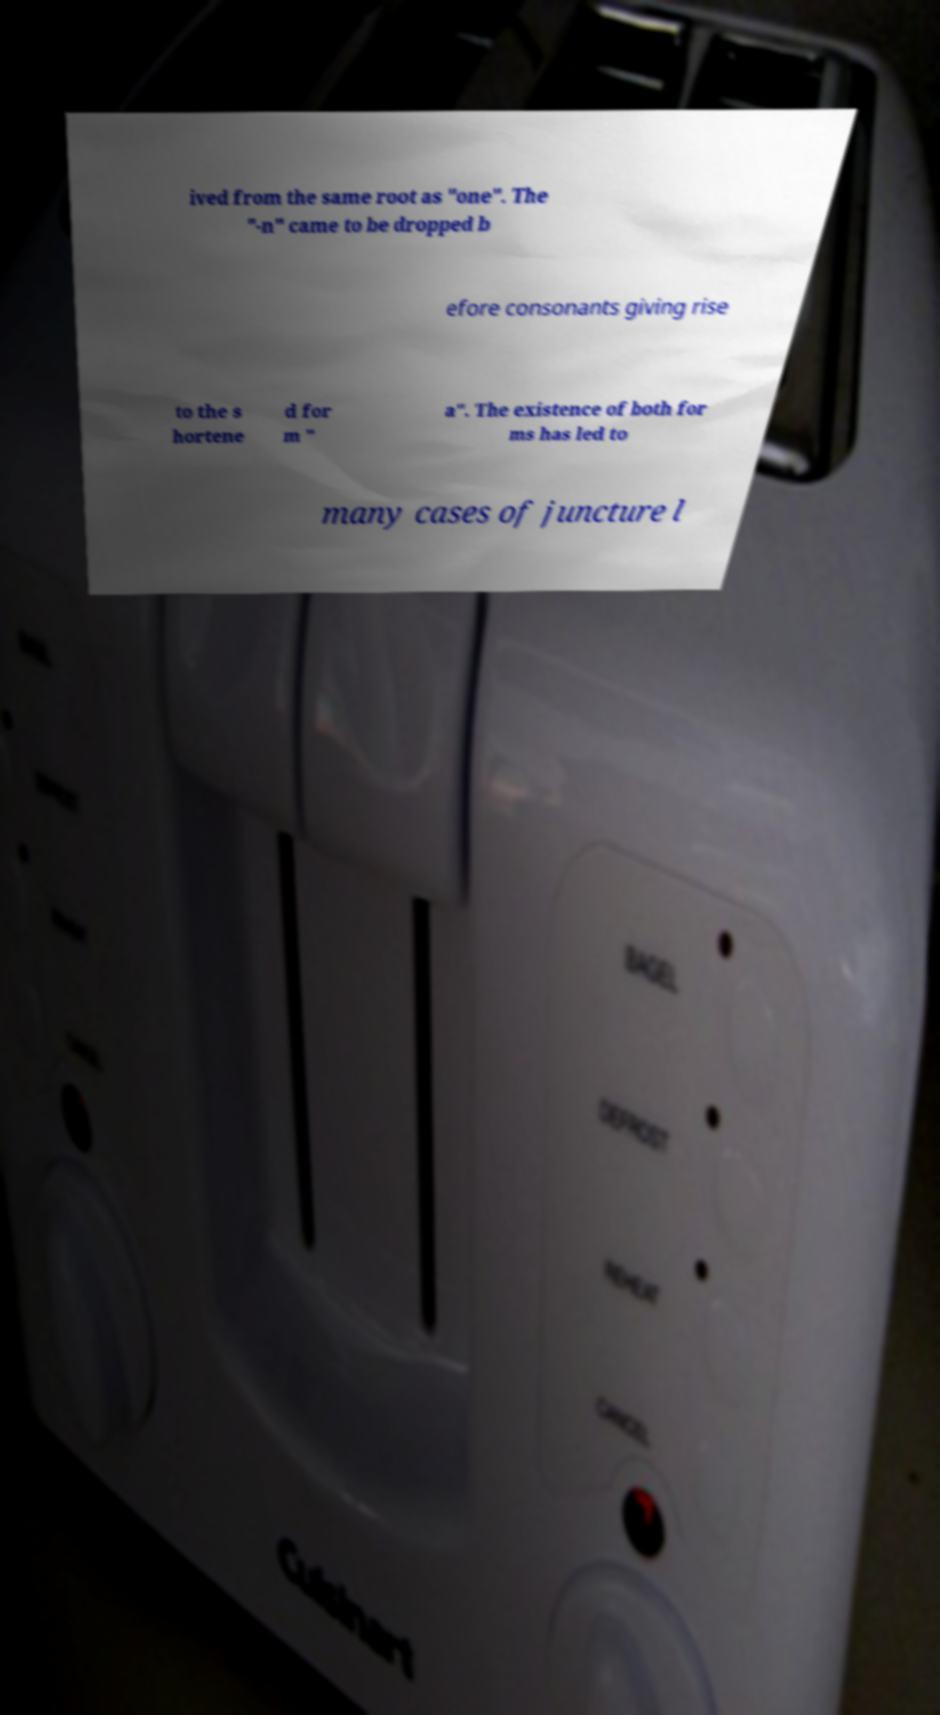There's text embedded in this image that I need extracted. Can you transcribe it verbatim? ived from the same root as "one". The "-n" came to be dropped b efore consonants giving rise to the s hortene d for m " a". The existence of both for ms has led to many cases of juncture l 